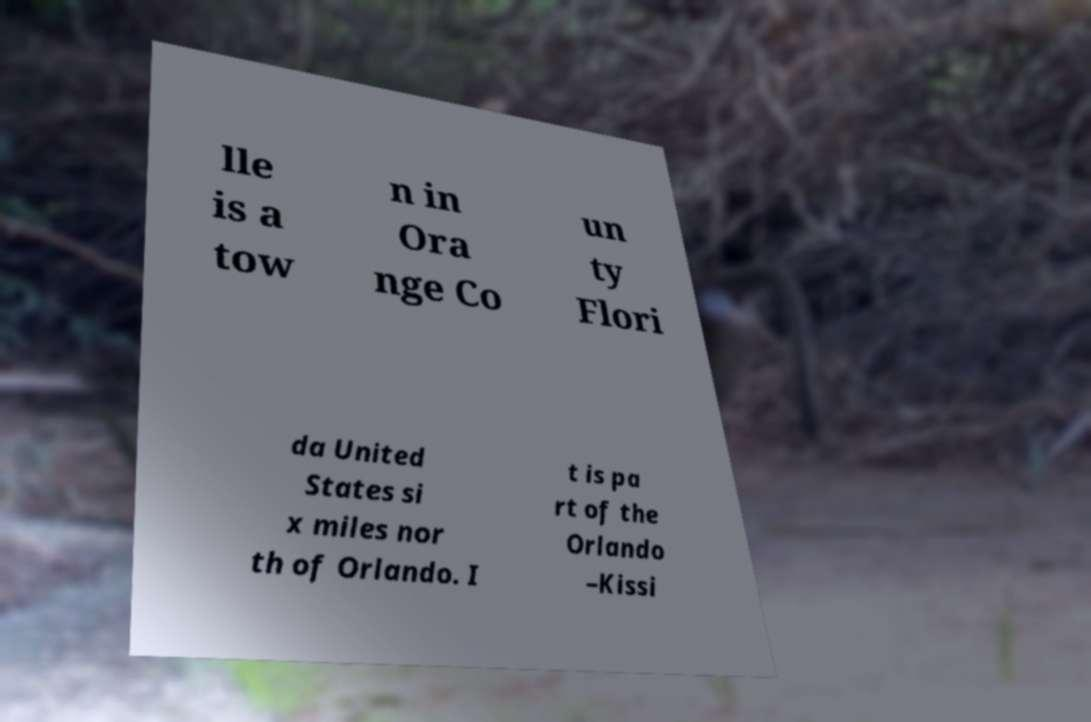Could you extract and type out the text from this image? lle is a tow n in Ora nge Co un ty Flori da United States si x miles nor th of Orlando. I t is pa rt of the Orlando –Kissi 